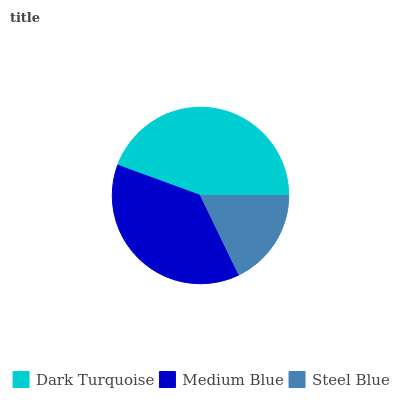Is Steel Blue the minimum?
Answer yes or no. Yes. Is Dark Turquoise the maximum?
Answer yes or no. Yes. Is Medium Blue the minimum?
Answer yes or no. No. Is Medium Blue the maximum?
Answer yes or no. No. Is Dark Turquoise greater than Medium Blue?
Answer yes or no. Yes. Is Medium Blue less than Dark Turquoise?
Answer yes or no. Yes. Is Medium Blue greater than Dark Turquoise?
Answer yes or no. No. Is Dark Turquoise less than Medium Blue?
Answer yes or no. No. Is Medium Blue the high median?
Answer yes or no. Yes. Is Medium Blue the low median?
Answer yes or no. Yes. Is Steel Blue the high median?
Answer yes or no. No. Is Dark Turquoise the low median?
Answer yes or no. No. 